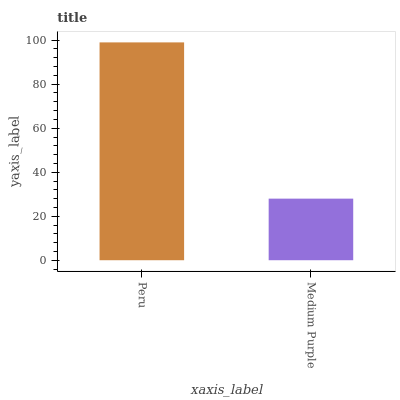Is Medium Purple the minimum?
Answer yes or no. Yes. Is Peru the maximum?
Answer yes or no. Yes. Is Medium Purple the maximum?
Answer yes or no. No. Is Peru greater than Medium Purple?
Answer yes or no. Yes. Is Medium Purple less than Peru?
Answer yes or no. Yes. Is Medium Purple greater than Peru?
Answer yes or no. No. Is Peru less than Medium Purple?
Answer yes or no. No. Is Peru the high median?
Answer yes or no. Yes. Is Medium Purple the low median?
Answer yes or no. Yes. Is Medium Purple the high median?
Answer yes or no. No. Is Peru the low median?
Answer yes or no. No. 